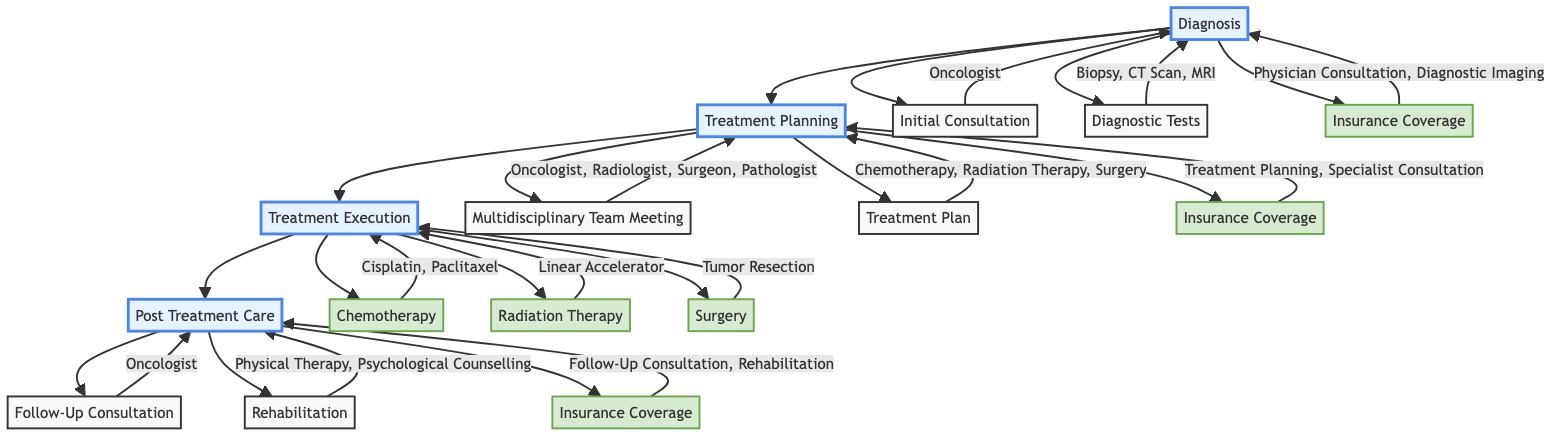What's the first step in the Cancer Treatment Pathway? The first step is "Diagnosis," which is represented as the starting point in the diagram.
Answer: Diagnosis How many specialists are involved in the Treatment Planning stage? In the Treatment Planning stage, there are four specialists listed: Oncologist, Radiologist, Surgeon, and Pathologist. Counting these gives a total of four specialists.
Answer: 4 What types of Diagnostic Tests are included? The types of Diagnostic Tests mentioned are Biopsy, CT Scan, and MRI. These are connected to the Diagnosis node in the diagram.
Answer: Biopsy, CT Scan, MRI Which drugs are included in the Chemotherapy treatment? The Chemotherapy treatment specifically lists Cisplatin and Paclitaxel as the drugs used in this stage, as per the Treatment Execution section of the diagram.
Answer: Cisplatin, Paclitaxel What is covered under Insurance Coverage in Post Treatment Care? In the Post Treatment Care stage, the Insurance Coverage includes Follow-Up Consultation Coverage and Rehabilitation Coverage as indicated in the diagram.
Answer: Follow-Up Consultation Coverage, Rehabilitation Coverage What is the duration of the hospital stay for Surgery? The duration of the hospital stay for Surgery is indicated as 3-7 days in the Treatment Execution section of the diagram.
Answer: 3-7 days Which therapy uses a Linear Accelerator? Radiation Therapy is the therapy that uses a Linear Accelerator, as specified in the Treatment Execution segment of the diagram.
Answer: Radiation Therapy How many different treatment plans are suggested? The Treatment Plan suggests three specific plans: Chemotherapy Plan, Radiation Therapy Plan, and Surgery Plan, resulting in a total of three treatment plans.
Answer: 3 What is included in the Rehabilitation stage after treatment? The Rehabilitation stage includes Physical Therapy and Psychological Counselling, which are listed in the Post Treatment Care section of the diagram.
Answer: Physical Therapy, Psychological Counselling 